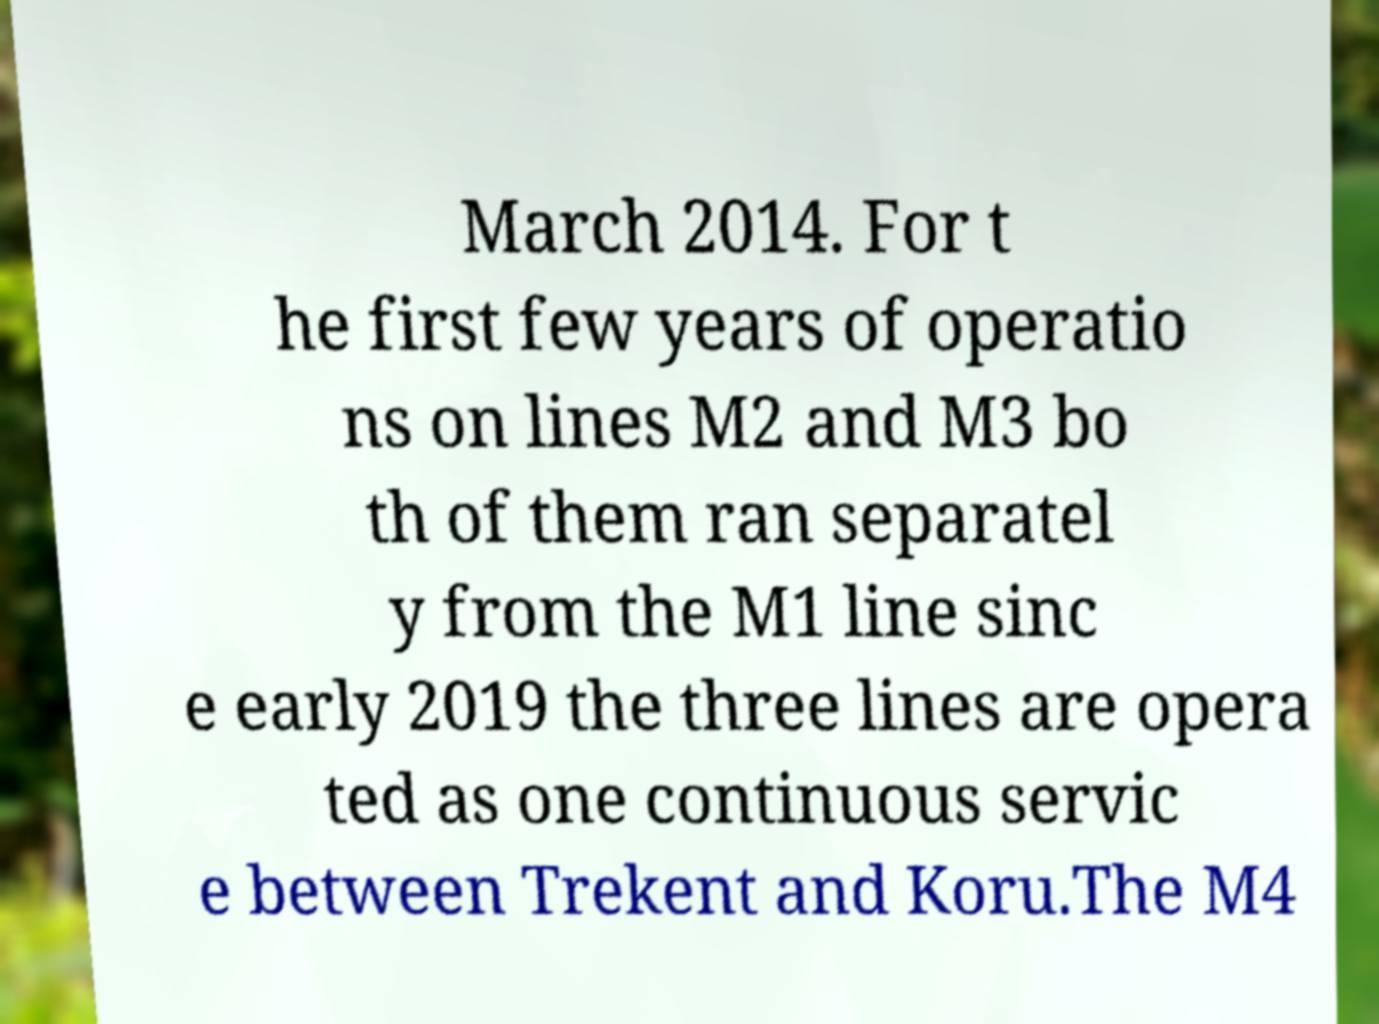Please read and relay the text visible in this image. What does it say? March 2014. For t he first few years of operatio ns on lines M2 and M3 bo th of them ran separatel y from the M1 line sinc e early 2019 the three lines are opera ted as one continuous servic e between Trekent and Koru.The M4 